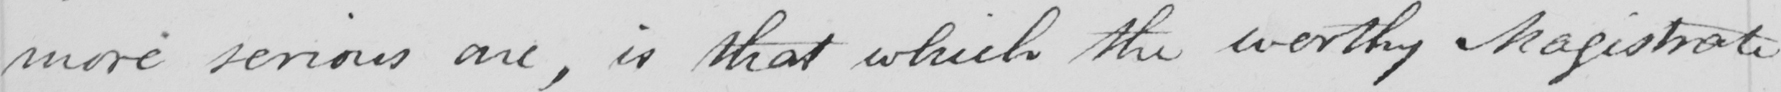Please transcribe the handwritten text in this image. more serious one , is that which the worthy Magistrate 